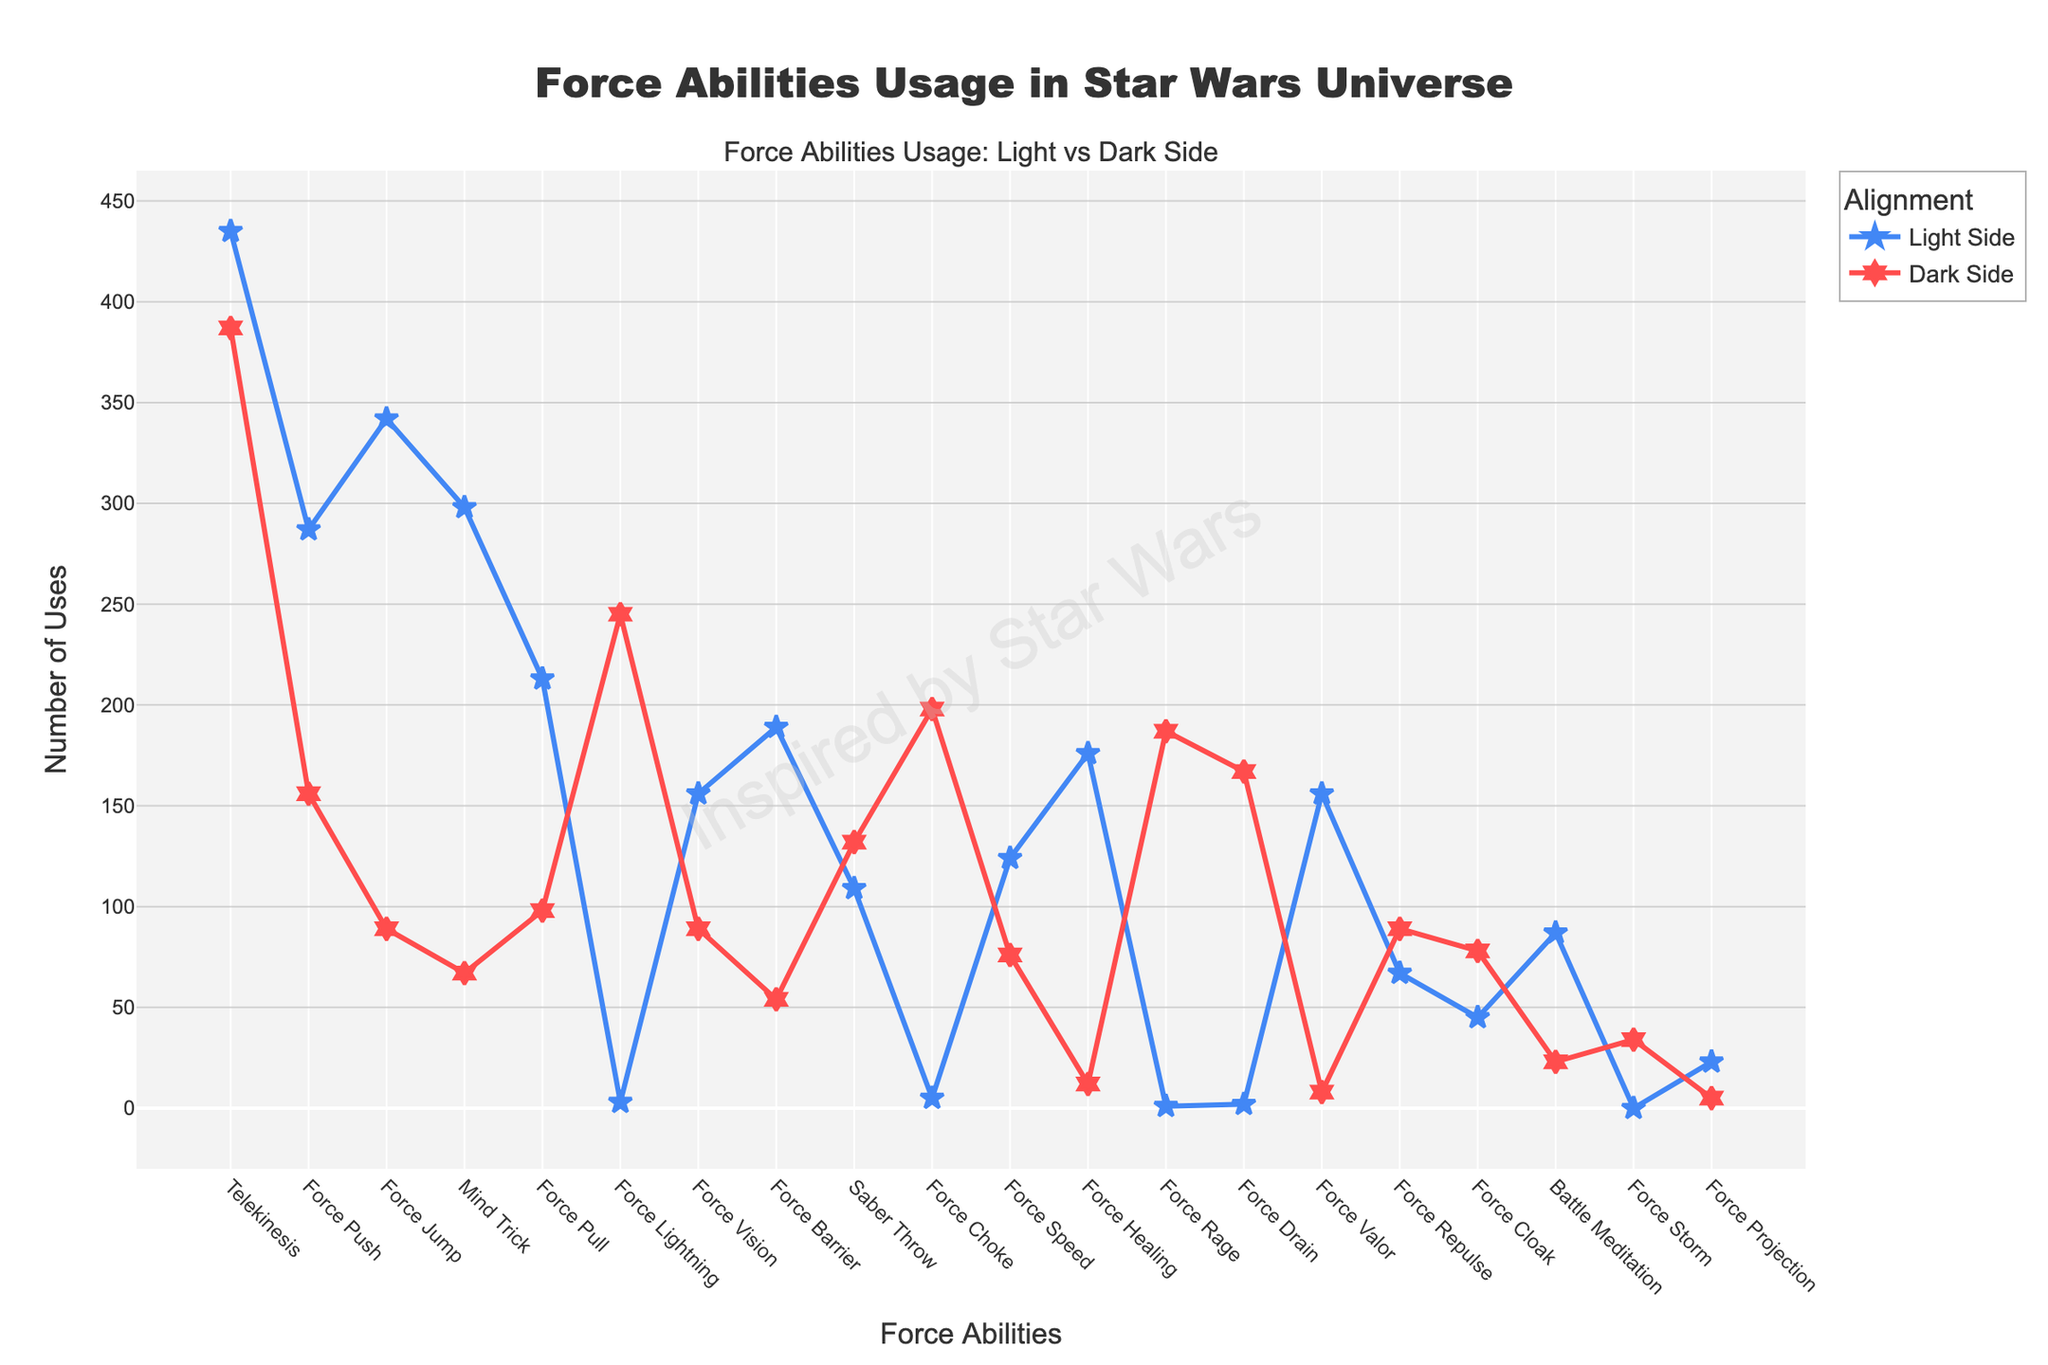Which Force ability has the highest usage by characters on the light side? By looking at the heights of the blue lines, the highest point corresponds to Telekinesis.
Answer: Telekinesis Which Force ability has the highest usage by characters on the dark side? By looking at the heights of the red lines, the highest point corresponds to Telekinesis.
Answer: Telekinesis How many times is Force Healing used by both light side and dark side characters combined? Add the use counts for Force Healing (Light Side) and Force Healing (Dark Side): 176 + 12.
Answer: 188 For Force Push, which side has more uses and by how much? Subtract the dark side uses from the light side uses for Force Push: 287 - 156.
Answer: Light Side, 131 more uses What is the total usage of Force Lightning? Add the usage counts for light and dark side for Force Lightning: 3 (Light Side) + 245 (Dark Side).
Answer: 248 Which side uses Mind Trick more frequently? Compare the light and dark side values for Mind Trick: 298 (Light Side) vs 67 (Dark Side).
Answer: Light Side What is the overall usage difference between Force Choke and Force Healing? First, calculate the total usages: Force Choke = 5 + 198 = 203 and Force Healing = 176 + 12 = 188. Then subtract the lower value from the higher value: 203 - 188.
Answer: 15 Which Force ability has zero uses on either the light or dark side and which side is it? Force Storm has zero uses on the light side.
Answer: Force Storm, light side Calculate the average usage of Force abilities by light side characters. Sum all light side uses and divide by the number of abilities: (287 + 213 + 342 + 176 + 3 + 5 + 298 + 156 + 124 + 435 + 189 + 2 + 87 + 45 + 109 + 156 + 1 + 67 + 23 + 0) / 20 = 2719 / 20.
Answer: 136 Does Force Cloak have higher usage on the light side or the dark side? Compare the light and dark side values for Force Cloak: 45 (Light Side) vs 78 (Dark Side).
Answer: Dark Side 